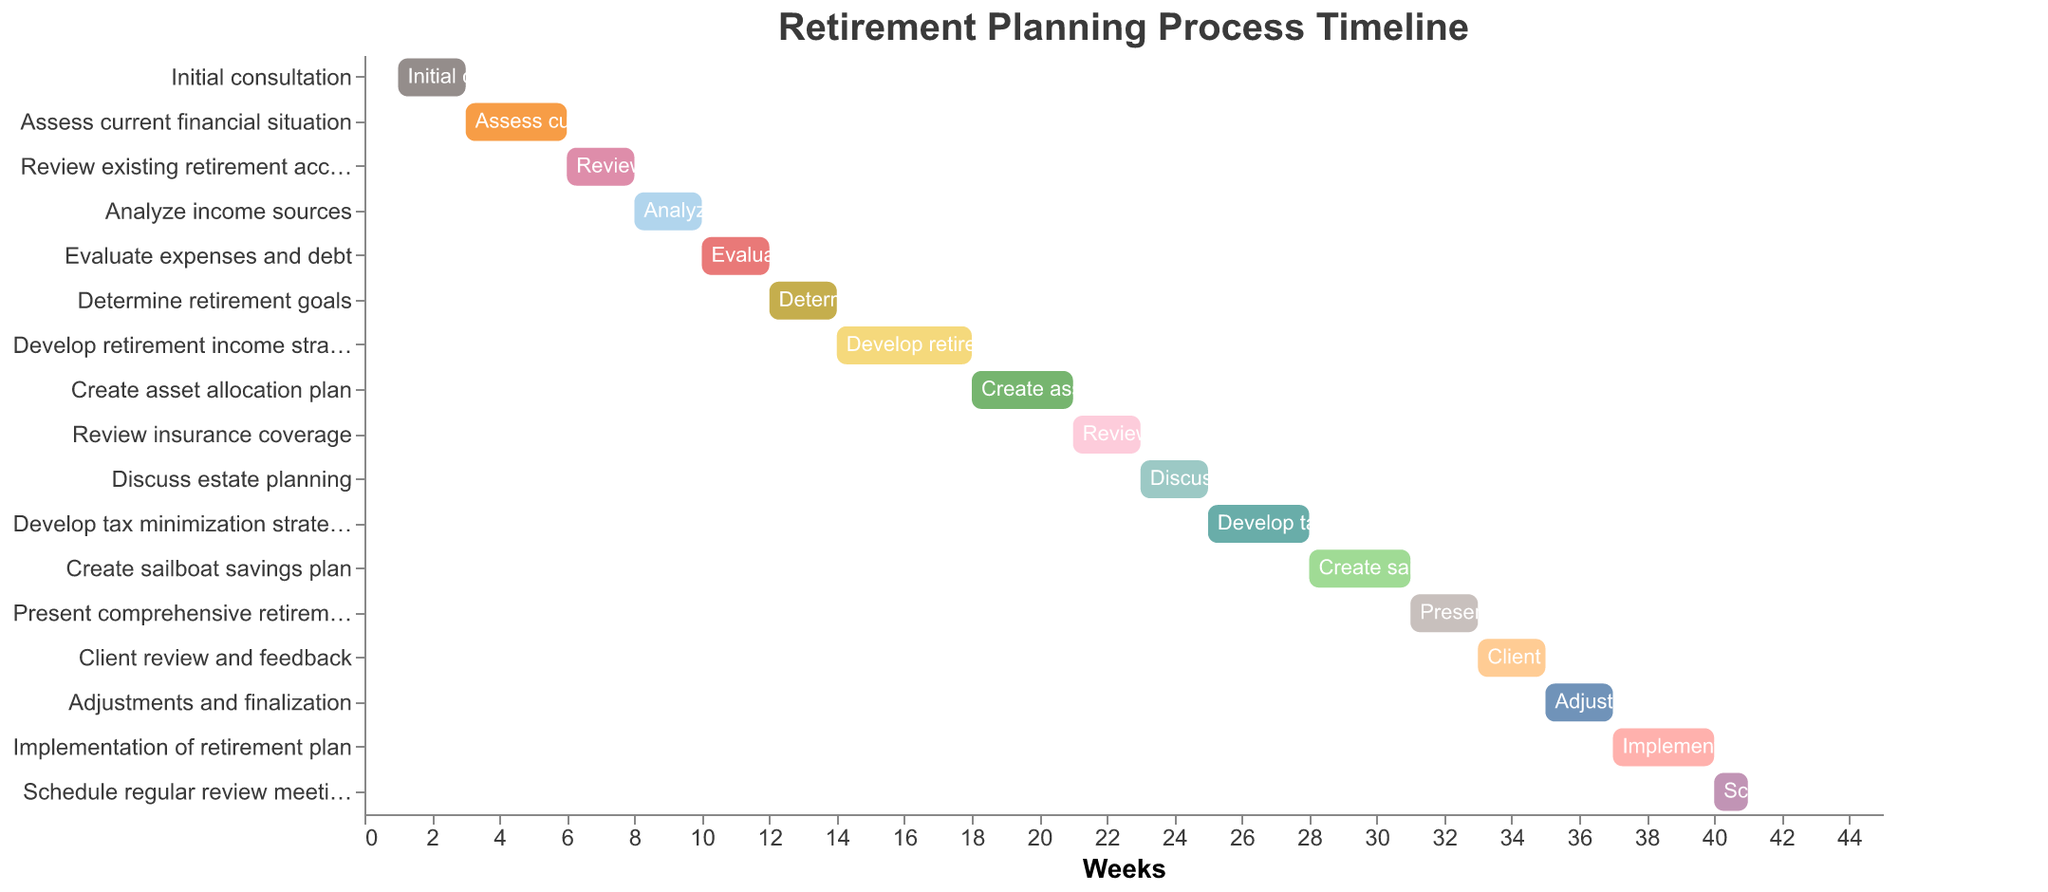What is the title of the Gantt Chart? The title is presented prominently at the top of the chart. From the data provided, it is "Retirement Planning Process Timeline".
Answer: Retirement Planning Process Timeline How many tasks are represented in the Gantt Chart? Each row in the Gantt Chart represents a task. The data provided lists 17 tasks.
Answer: 17 When does the "Create sailboat savings plan" task start and how long does it last? Refer to the "Start" and "Duration" fields for the "Create sailboat savings plan" task. It starts at week 28 and lasts for 3 weeks.
Answer: Week 28, 3 weeks Which task has the longest duration? From the data, check the "Duration" field for each task and identify the task with the highest duration value. The longest duration is for "Develop retirement income strategy," which lasts 4 weeks.
Answer: Develop retirement income strategy Which task(s) overlap with "Create asset allocation plan"? The "Create asset allocation plan" task starts at week 18 and lasts for 3 weeks (until week 21). Check other tasks to see which ones have a start or end within this period. "Develop retirement income strategy" (week 14-18) ends where "Create asset allocation plan" begins, and "Review insurance coverage" (week 21-23) starts where "Create asset allocation plan" ends, hence overlap occurs at weeks 18 and 21 respectively.
Answer: Develop retirement income strategy, Review insurance coverage How many tasks end after week 30? To find this, look for tasks where the "Start" plus "Duration" (i.e., the end week) is greater than 30. Tasks starting at or after week 31 or tasks starting before and lasting beyond week 30. There are several: "Create sailboat savings plan," which ends at week 31, "Present comprehensive retirement plan," "Client review and feedback," "Adjustments and finalization," "Implementation of retirement plan," and "Schedule regular review meetings." This results in 6 tasks in total.
Answer: 6 What percentage of the total timeline is dedicated to the "Implementation of retirement plan" task if the chart spans from week 1 to week 41? First, calculate the total timeline from week 1 to week 41, which is 41 weeks. "Implementation of retirement plan" starts at week 37 and lasts 3 weeks. The percentage is (3/41) * 100.
Answer: Approximately 7.32% In terms of sequence, which task comes directly after the "Evaluate expenses and debt" task? According to the data, "Evaluate expenses and debt" starts at week 10 and lasts for 2 weeks. The task that starts immediately after this at week 12 is "Determine retirement goals."
Answer: Determine retirement goals On average, how many weeks does each task last? Sum the durations of all tasks and then divide by the number of tasks. Total duration is (2+3+2+2+2+2+4+3+2+2+3+3+2+2+2+3+1) = 40 weeks. Divide by 17 tasks: 40/17.
Answer: Approximately 2.35 weeks 